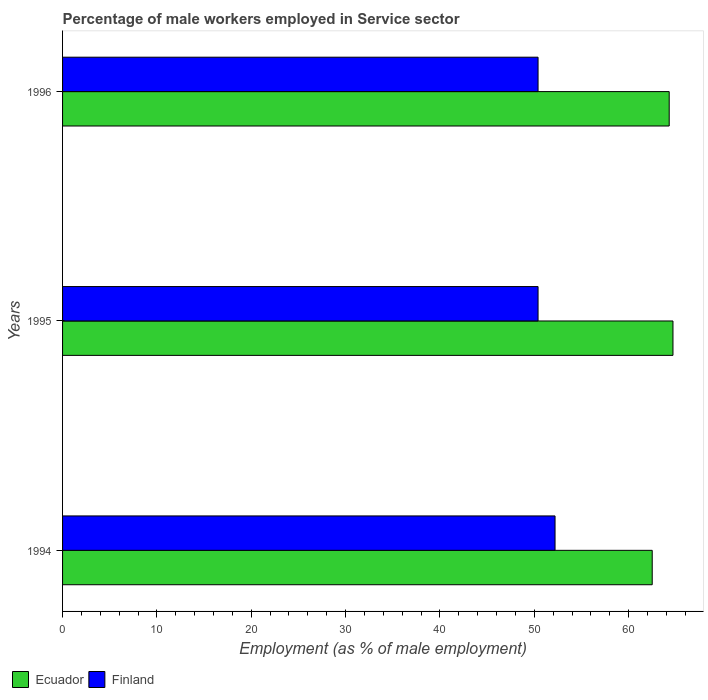How many different coloured bars are there?
Provide a succinct answer. 2. Are the number of bars per tick equal to the number of legend labels?
Your answer should be compact. Yes. Are the number of bars on each tick of the Y-axis equal?
Keep it short and to the point. Yes. How many bars are there on the 2nd tick from the top?
Your response must be concise. 2. What is the label of the 2nd group of bars from the top?
Your response must be concise. 1995. What is the percentage of male workers employed in Service sector in Finland in 1995?
Offer a terse response. 50.4. Across all years, what is the maximum percentage of male workers employed in Service sector in Finland?
Give a very brief answer. 52.2. Across all years, what is the minimum percentage of male workers employed in Service sector in Finland?
Provide a succinct answer. 50.4. What is the total percentage of male workers employed in Service sector in Finland in the graph?
Offer a very short reply. 153. What is the difference between the percentage of male workers employed in Service sector in Finland in 1996 and the percentage of male workers employed in Service sector in Ecuador in 1995?
Your answer should be compact. -14.3. What is the average percentage of male workers employed in Service sector in Finland per year?
Keep it short and to the point. 51. In the year 1996, what is the difference between the percentage of male workers employed in Service sector in Ecuador and percentage of male workers employed in Service sector in Finland?
Offer a very short reply. 13.9. In how many years, is the percentage of male workers employed in Service sector in Ecuador greater than 6 %?
Offer a terse response. 3. What is the ratio of the percentage of male workers employed in Service sector in Ecuador in 1994 to that in 1996?
Make the answer very short. 0.97. Is the percentage of male workers employed in Service sector in Finland in 1994 less than that in 1995?
Offer a very short reply. No. What is the difference between the highest and the second highest percentage of male workers employed in Service sector in Finland?
Ensure brevity in your answer.  1.8. What is the difference between the highest and the lowest percentage of male workers employed in Service sector in Finland?
Your response must be concise. 1.8. What does the 1st bar from the top in 1995 represents?
Ensure brevity in your answer.  Finland. How many bars are there?
Make the answer very short. 6. How many years are there in the graph?
Make the answer very short. 3. What is the difference between two consecutive major ticks on the X-axis?
Ensure brevity in your answer.  10. Are the values on the major ticks of X-axis written in scientific E-notation?
Provide a succinct answer. No. How many legend labels are there?
Ensure brevity in your answer.  2. How are the legend labels stacked?
Provide a short and direct response. Horizontal. What is the title of the graph?
Your answer should be very brief. Percentage of male workers employed in Service sector. Does "Austria" appear as one of the legend labels in the graph?
Keep it short and to the point. No. What is the label or title of the X-axis?
Offer a very short reply. Employment (as % of male employment). What is the label or title of the Y-axis?
Your answer should be compact. Years. What is the Employment (as % of male employment) in Ecuador in 1994?
Offer a terse response. 62.5. What is the Employment (as % of male employment) in Finland in 1994?
Provide a short and direct response. 52.2. What is the Employment (as % of male employment) of Ecuador in 1995?
Your answer should be very brief. 64.7. What is the Employment (as % of male employment) in Finland in 1995?
Your answer should be compact. 50.4. What is the Employment (as % of male employment) in Ecuador in 1996?
Keep it short and to the point. 64.3. What is the Employment (as % of male employment) of Finland in 1996?
Your response must be concise. 50.4. Across all years, what is the maximum Employment (as % of male employment) in Ecuador?
Your answer should be compact. 64.7. Across all years, what is the maximum Employment (as % of male employment) of Finland?
Ensure brevity in your answer.  52.2. Across all years, what is the minimum Employment (as % of male employment) in Ecuador?
Give a very brief answer. 62.5. Across all years, what is the minimum Employment (as % of male employment) of Finland?
Your response must be concise. 50.4. What is the total Employment (as % of male employment) in Ecuador in the graph?
Provide a short and direct response. 191.5. What is the total Employment (as % of male employment) in Finland in the graph?
Your answer should be compact. 153. What is the difference between the Employment (as % of male employment) of Finland in 1994 and that in 1995?
Give a very brief answer. 1.8. What is the difference between the Employment (as % of male employment) of Ecuador in 1994 and that in 1996?
Give a very brief answer. -1.8. What is the difference between the Employment (as % of male employment) in Ecuador in 1995 and that in 1996?
Give a very brief answer. 0.4. What is the difference between the Employment (as % of male employment) in Ecuador in 1994 and the Employment (as % of male employment) in Finland in 1995?
Your answer should be very brief. 12.1. What is the average Employment (as % of male employment) of Ecuador per year?
Offer a terse response. 63.83. What is the average Employment (as % of male employment) in Finland per year?
Provide a short and direct response. 51. In the year 1994, what is the difference between the Employment (as % of male employment) in Ecuador and Employment (as % of male employment) in Finland?
Make the answer very short. 10.3. What is the ratio of the Employment (as % of male employment) of Ecuador in 1994 to that in 1995?
Your response must be concise. 0.97. What is the ratio of the Employment (as % of male employment) in Finland in 1994 to that in 1995?
Provide a short and direct response. 1.04. What is the ratio of the Employment (as % of male employment) in Ecuador in 1994 to that in 1996?
Provide a succinct answer. 0.97. What is the ratio of the Employment (as % of male employment) in Finland in 1994 to that in 1996?
Provide a succinct answer. 1.04. What is the ratio of the Employment (as % of male employment) of Finland in 1995 to that in 1996?
Offer a very short reply. 1. What is the difference between the highest and the lowest Employment (as % of male employment) of Finland?
Offer a very short reply. 1.8. 